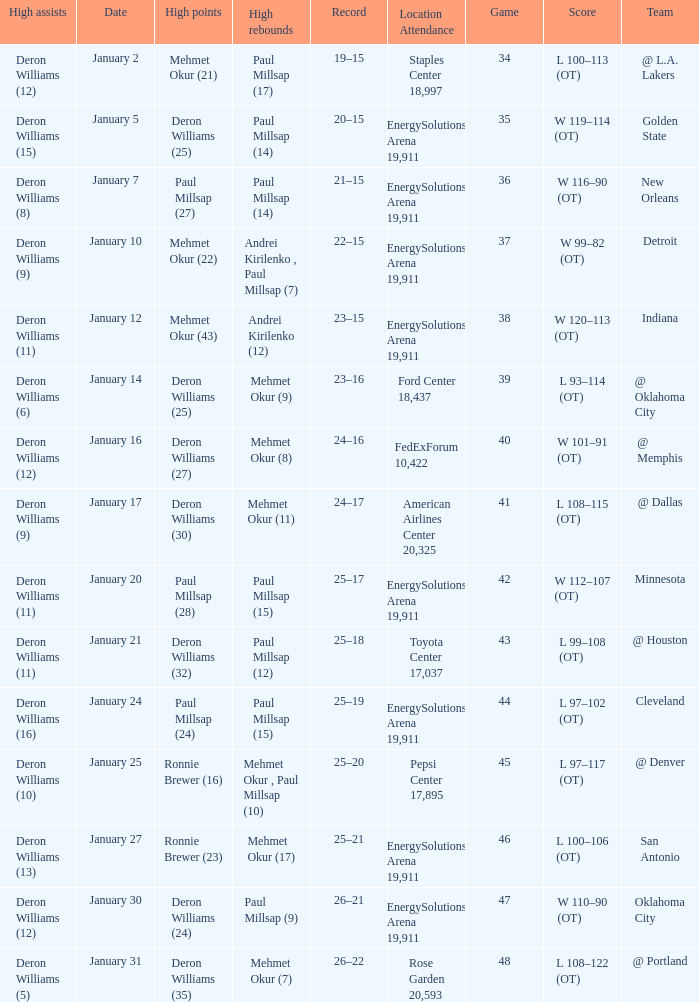Give me the full table as a dictionary. {'header': ['High assists', 'Date', 'High points', 'High rebounds', 'Record', 'Location Attendance', 'Game', 'Score', 'Team'], 'rows': [['Deron Williams (12)', 'January 2', 'Mehmet Okur (21)', 'Paul Millsap (17)', '19–15', 'Staples Center 18,997', '34', 'L 100–113 (OT)', '@ L.A. Lakers'], ['Deron Williams (15)', 'January 5', 'Deron Williams (25)', 'Paul Millsap (14)', '20–15', 'EnergySolutions Arena 19,911', '35', 'W 119–114 (OT)', 'Golden State'], ['Deron Williams (8)', 'January 7', 'Paul Millsap (27)', 'Paul Millsap (14)', '21–15', 'EnergySolutions Arena 19,911', '36', 'W 116–90 (OT)', 'New Orleans'], ['Deron Williams (9)', 'January 10', 'Mehmet Okur (22)', 'Andrei Kirilenko , Paul Millsap (7)', '22–15', 'EnergySolutions Arena 19,911', '37', 'W 99–82 (OT)', 'Detroit'], ['Deron Williams (11)', 'January 12', 'Mehmet Okur (43)', 'Andrei Kirilenko (12)', '23–15', 'EnergySolutions Arena 19,911', '38', 'W 120–113 (OT)', 'Indiana'], ['Deron Williams (6)', 'January 14', 'Deron Williams (25)', 'Mehmet Okur (9)', '23–16', 'Ford Center 18,437', '39', 'L 93–114 (OT)', '@ Oklahoma City'], ['Deron Williams (12)', 'January 16', 'Deron Williams (27)', 'Mehmet Okur (8)', '24–16', 'FedExForum 10,422', '40', 'W 101–91 (OT)', '@ Memphis'], ['Deron Williams (9)', 'January 17', 'Deron Williams (30)', 'Mehmet Okur (11)', '24–17', 'American Airlines Center 20,325', '41', 'L 108–115 (OT)', '@ Dallas'], ['Deron Williams (11)', 'January 20', 'Paul Millsap (28)', 'Paul Millsap (15)', '25–17', 'EnergySolutions Arena 19,911', '42', 'W 112–107 (OT)', 'Minnesota'], ['Deron Williams (11)', 'January 21', 'Deron Williams (32)', 'Paul Millsap (12)', '25–18', 'Toyota Center 17,037', '43', 'L 99–108 (OT)', '@ Houston'], ['Deron Williams (16)', 'January 24', 'Paul Millsap (24)', 'Paul Millsap (15)', '25–19', 'EnergySolutions Arena 19,911', '44', 'L 97–102 (OT)', 'Cleveland'], ['Deron Williams (10)', 'January 25', 'Ronnie Brewer (16)', 'Mehmet Okur , Paul Millsap (10)', '25–20', 'Pepsi Center 17,895', '45', 'L 97–117 (OT)', '@ Denver'], ['Deron Williams (13)', 'January 27', 'Ronnie Brewer (23)', 'Mehmet Okur (17)', '25–21', 'EnergySolutions Arena 19,911', '46', 'L 100–106 (OT)', 'San Antonio'], ['Deron Williams (12)', 'January 30', 'Deron Williams (24)', 'Paul Millsap (9)', '26–21', 'EnergySolutions Arena 19,911', '47', 'W 110–90 (OT)', 'Oklahoma City'], ['Deron Williams (5)', 'January 31', 'Deron Williams (35)', 'Mehmet Okur (7)', '26–22', 'Rose Garden 20,593', '48', 'L 108–122 (OT)', '@ Portland']]} What was the score of Game 48? L 108–122 (OT). 